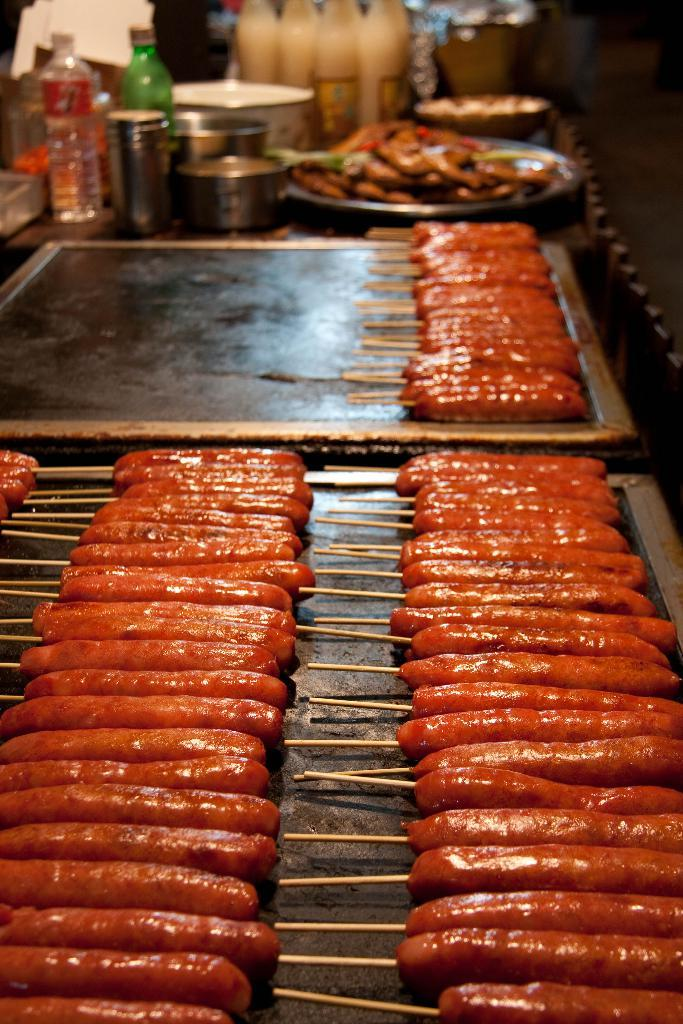What is the main food item on the table in the image? Unfortunately, the specific food item is not mentioned in the provided facts. However, we know that there is a food item on the table. What else can be seen on the table besides the food item? There are bottles and other objects on the table. Can you describe the bottles on the table? Unfortunately, the specific details about the bottles are not mentioned in the provided facts. However, we know that there are bottles on the table. What rhythm is the arm playing on the table in the image? There is no arm or any musical instrument present in the image, so it is not possible to determine if any rhythm is being played. 